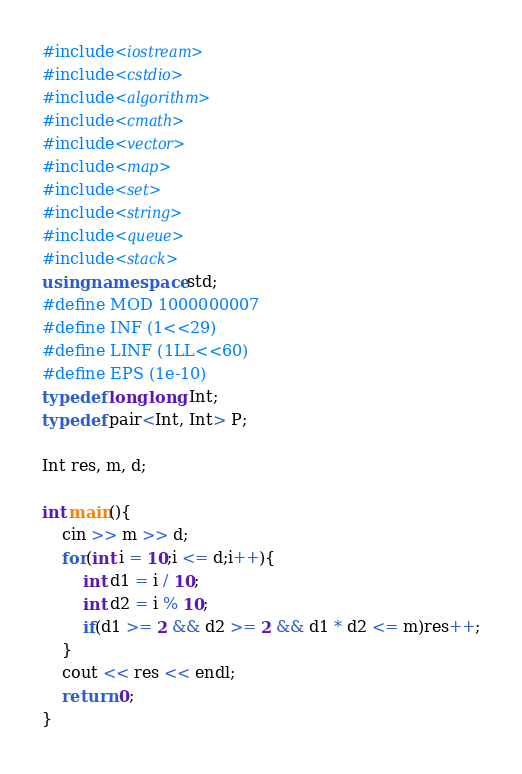Convert code to text. <code><loc_0><loc_0><loc_500><loc_500><_C++_>#include<iostream>
#include<cstdio>
#include<algorithm>
#include<cmath>
#include<vector>
#include<map>
#include<set>
#include<string>
#include<queue>
#include<stack>
using namespace std;
#define MOD 1000000007
#define INF (1<<29)
#define LINF (1LL<<60)
#define EPS (1e-10)
typedef long long Int;
typedef pair<Int, Int> P;

Int res, m, d;

int main(){
    cin >> m >> d;
    for(int i = 10;i <= d;i++){
        int d1 = i / 10;
        int d2 = i % 10;
        if(d1 >= 2 && d2 >= 2 && d1 * d2 <= m)res++;
    }
    cout << res << endl;
    return 0;
}</code> 